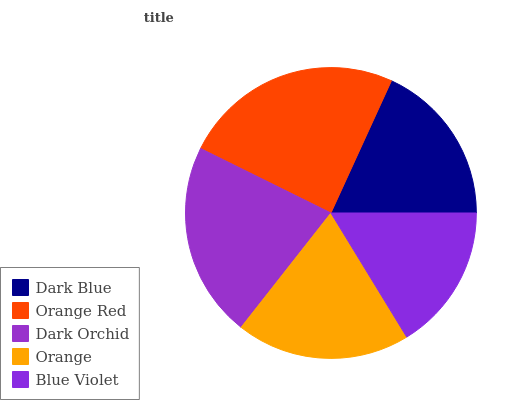Is Blue Violet the minimum?
Answer yes or no. Yes. Is Orange Red the maximum?
Answer yes or no. Yes. Is Dark Orchid the minimum?
Answer yes or no. No. Is Dark Orchid the maximum?
Answer yes or no. No. Is Orange Red greater than Dark Orchid?
Answer yes or no. Yes. Is Dark Orchid less than Orange Red?
Answer yes or no. Yes. Is Dark Orchid greater than Orange Red?
Answer yes or no. No. Is Orange Red less than Dark Orchid?
Answer yes or no. No. Is Orange the high median?
Answer yes or no. Yes. Is Orange the low median?
Answer yes or no. Yes. Is Dark Orchid the high median?
Answer yes or no. No. Is Dark Orchid the low median?
Answer yes or no. No. 